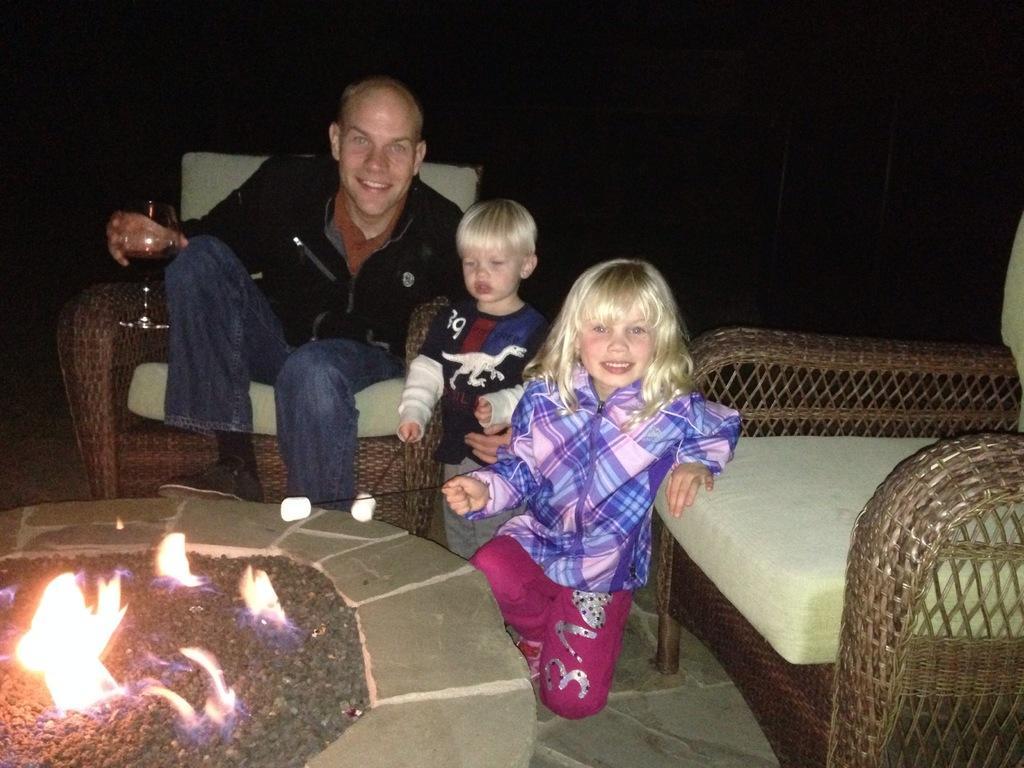Describe this image in one or two sentences. Here we can see a group of person sitting on the chair, and holding a wine glass in the hand, and here is the chair, and here is the fire. 